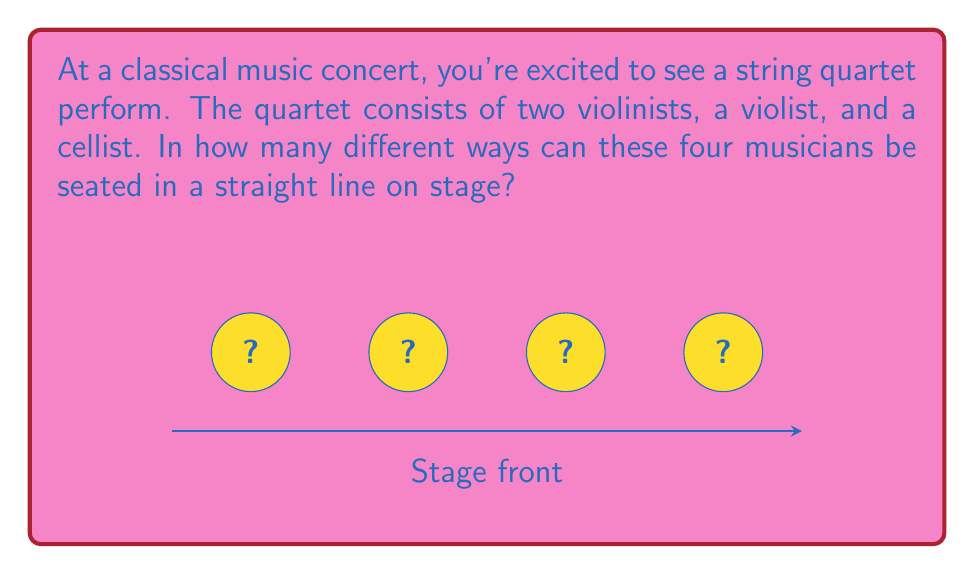Provide a solution to this math problem. Let's approach this step-by-step:

1) This is a permutation problem. We need to arrange 4 distinct people in a line.

2) For the first position, we have 4 choices.

3) After placing the first musician, we have 3 choices for the second position.

4) For the third position, we'll have 2 choices left.

5) The last position will be filled by the remaining musician, so there's only 1 choice.

6) According to the multiplication principle, we multiply these numbers:

   $$ 4 \times 3 \times 2 \times 1 = 24 $$

7) This is also known as 4 factorial, written as 4!:

   $$ 4! = 4 \times 3 \times 2 \times 1 = 24 $$

Therefore, there are 24 different ways to arrange the quartet.
Answer: 24 